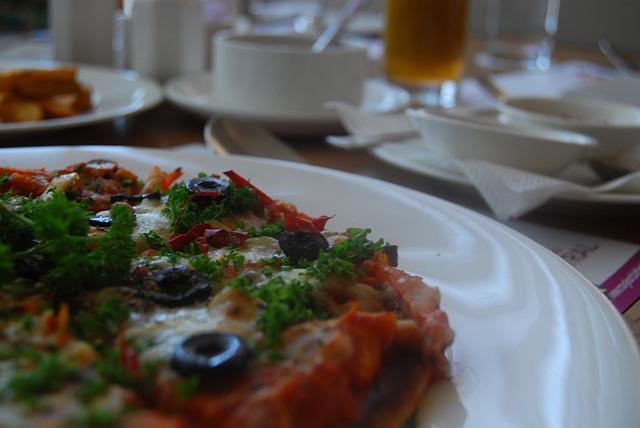How many dining tables are visible?
Give a very brief answer. 2. How many bowls are there?
Give a very brief answer. 4. How many cups are visible?
Give a very brief answer. 2. How many cars are in front of the motorcycle?
Give a very brief answer. 0. 